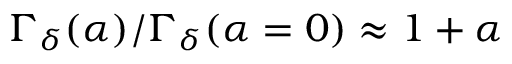<formula> <loc_0><loc_0><loc_500><loc_500>\Gamma _ { \delta } ( \alpha ) / \Gamma _ { \delta } ( \alpha = 0 ) \approx 1 + \alpha</formula> 